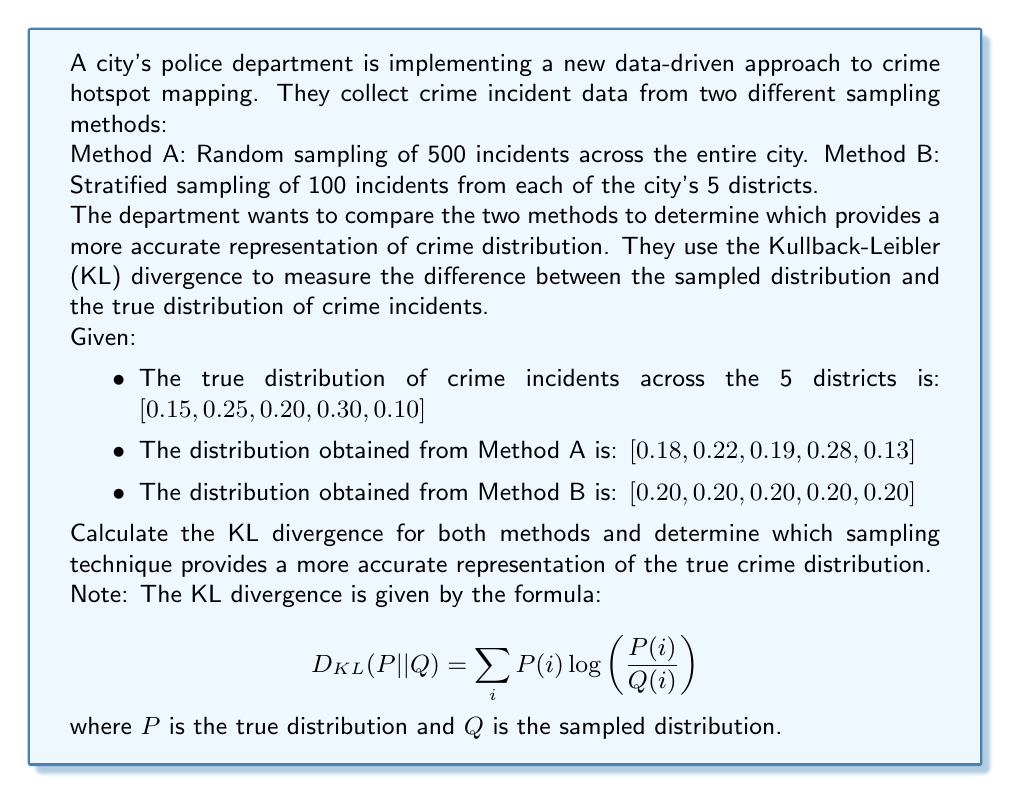Help me with this question. To solve this problem, we need to calculate the KL divergence for both sampling methods and compare the results. The method with the lower KL divergence will be considered more accurate.

Step 1: Calculate KL divergence for Method A

Let's use the given formula:

$$ D_{KL}(P || Q_A) = \sum_{i} P(i) \log \left(\frac{P(i)}{Q_A(i)}\right) $$

We'll calculate each term separately:

1. $0.15 \log(0.15/0.18) = -0.0080$
2. $0.25 \log(0.25/0.22) = 0.0137$
3. $0.20 \log(0.20/0.19) = 0.0045$
4. $0.30 \log(0.30/0.28) = 0.0058$
5. $0.10 \log(0.10/0.13) = -0.0112$

Sum these values:
$D_{KL}(P || Q_A) = -0.0080 + 0.0137 + 0.0045 + 0.0058 - 0.0112 = 0.0048$

Step 2: Calculate KL divergence for Method B

Using the same formula:

$$ D_{KL}(P || Q_B) = \sum_{i} P(i) \log \left(\frac{P(i)}{Q_B(i)}\right) $$

Calculate each term:

1. $0.15 \log(0.15/0.20) = -0.0195$
2. $0.25 \log(0.25/0.20) = 0.0406$
3. $0.20 \log(0.20/0.20) = 0$
4. $0.30 \log(0.30/0.20) = 0.1249$
5. $0.10 \log(0.10/0.20) = -0.0511$

Sum these values:
$D_{KL}(P || Q_B) = -0.0195 + 0.0406 + 0 + 0.1249 - 0.0511 = 0.0949$

Step 3: Compare the results

Method A: $D_{KL}(P || Q_A) = 0.0048$
Method B: $D_{KL}(P || Q_B) = 0.0949$

Since the KL divergence for Method A is lower, it provides a more accurate representation of the true crime distribution.
Answer: Method A (random sampling) provides a more accurate representation of the true crime distribution, with a KL divergence of 0.0048 compared to Method B's 0.0949. 